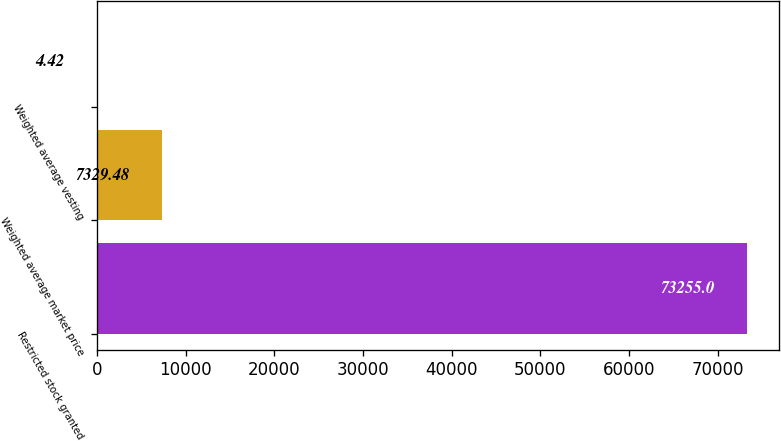Convert chart to OTSL. <chart><loc_0><loc_0><loc_500><loc_500><bar_chart><fcel>Restricted stock granted<fcel>Weighted average market price<fcel>Weighted average vesting<nl><fcel>73255<fcel>7329.48<fcel>4.42<nl></chart> 